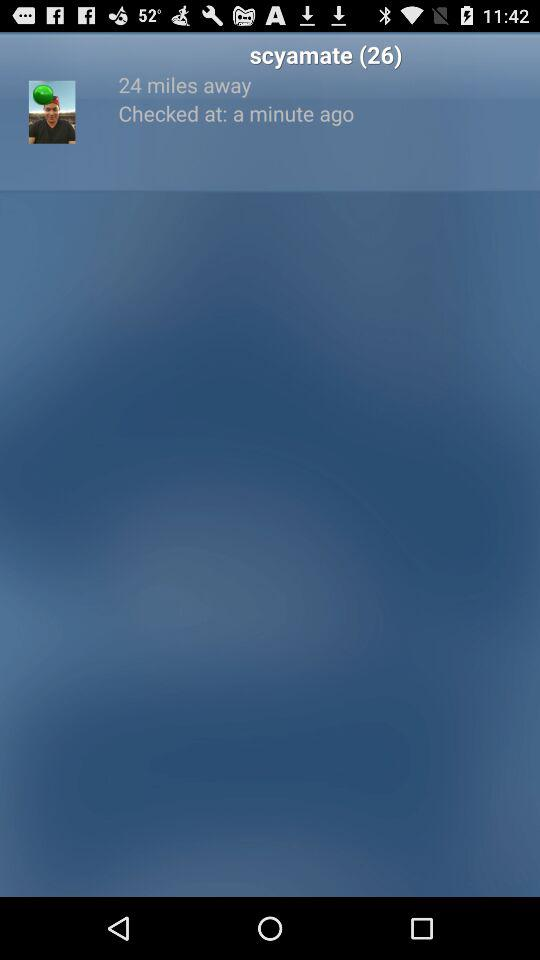How many miles away is Scyamate? Scyamate is 24 miles away. 